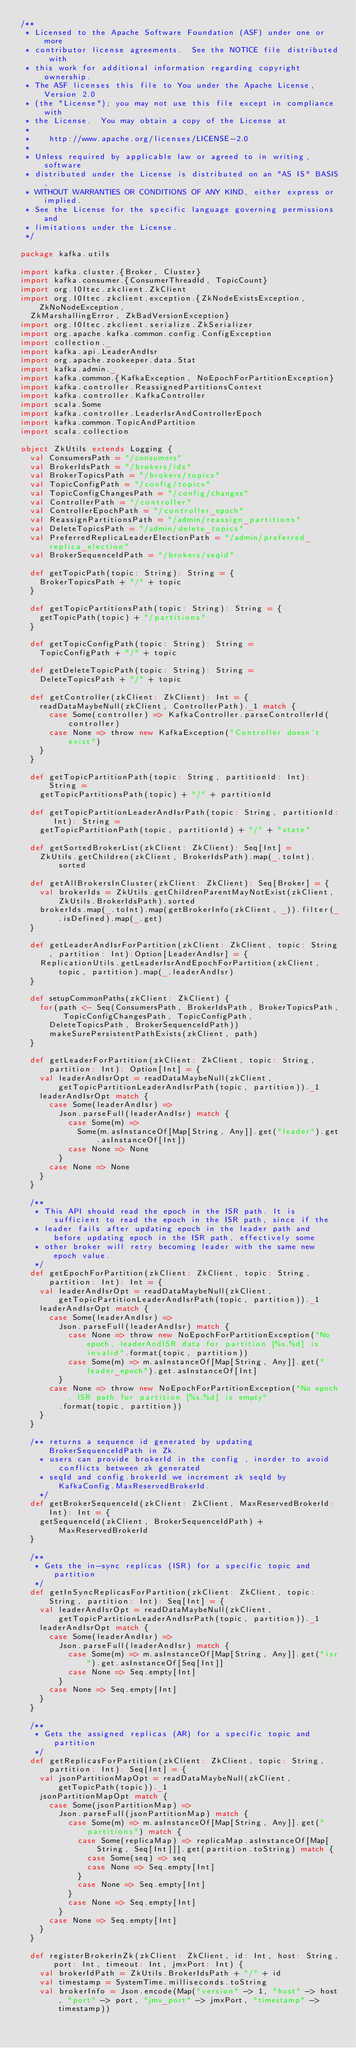Convert code to text. <code><loc_0><loc_0><loc_500><loc_500><_Scala_>/**
 * Licensed to the Apache Software Foundation (ASF) under one or more
 * contributor license agreements.  See the NOTICE file distributed with
 * this work for additional information regarding copyright ownership.
 * The ASF licenses this file to You under the Apache License, Version 2.0
 * (the "License"); you may not use this file except in compliance with
 * the License.  You may obtain a copy of the License at
 *
 *    http://www.apache.org/licenses/LICENSE-2.0
 *
 * Unless required by applicable law or agreed to in writing, software
 * distributed under the License is distributed on an "AS IS" BASIS,
 * WITHOUT WARRANTIES OR CONDITIONS OF ANY KIND, either express or implied.
 * See the License for the specific language governing permissions and
 * limitations under the License.
 */

package kafka.utils

import kafka.cluster.{Broker, Cluster}
import kafka.consumer.{ConsumerThreadId, TopicCount}
import org.I0Itec.zkclient.ZkClient
import org.I0Itec.zkclient.exception.{ZkNodeExistsException, ZkNoNodeException,
  ZkMarshallingError, ZkBadVersionException}
import org.I0Itec.zkclient.serialize.ZkSerializer
import org.apache.kafka.common.config.ConfigException
import collection._
import kafka.api.LeaderAndIsr
import org.apache.zookeeper.data.Stat
import kafka.admin._
import kafka.common.{KafkaException, NoEpochForPartitionException}
import kafka.controller.ReassignedPartitionsContext
import kafka.controller.KafkaController
import scala.Some
import kafka.controller.LeaderIsrAndControllerEpoch
import kafka.common.TopicAndPartition
import scala.collection

object ZkUtils extends Logging {
  val ConsumersPath = "/consumers"
  val BrokerIdsPath = "/brokers/ids"
  val BrokerTopicsPath = "/brokers/topics"
  val TopicConfigPath = "/config/topics"
  val TopicConfigChangesPath = "/config/changes"
  val ControllerPath = "/controller"
  val ControllerEpochPath = "/controller_epoch"
  val ReassignPartitionsPath = "/admin/reassign_partitions"
  val DeleteTopicsPath = "/admin/delete_topics"
  val PreferredReplicaLeaderElectionPath = "/admin/preferred_replica_election"
  val BrokerSequenceIdPath = "/brokers/seqid"

  def getTopicPath(topic: String): String = {
    BrokerTopicsPath + "/" + topic
  }

  def getTopicPartitionsPath(topic: String): String = {
    getTopicPath(topic) + "/partitions"
  }

  def getTopicConfigPath(topic: String): String =
    TopicConfigPath + "/" + topic

  def getDeleteTopicPath(topic: String): String =
    DeleteTopicsPath + "/" + topic

  def getController(zkClient: ZkClient): Int = {
    readDataMaybeNull(zkClient, ControllerPath)._1 match {
      case Some(controller) => KafkaController.parseControllerId(controller)
      case None => throw new KafkaException("Controller doesn't exist")
    }
  }

  def getTopicPartitionPath(topic: String, partitionId: Int): String =
    getTopicPartitionsPath(topic) + "/" + partitionId

  def getTopicPartitionLeaderAndIsrPath(topic: String, partitionId: Int): String =
    getTopicPartitionPath(topic, partitionId) + "/" + "state"

  def getSortedBrokerList(zkClient: ZkClient): Seq[Int] =
    ZkUtils.getChildren(zkClient, BrokerIdsPath).map(_.toInt).sorted

  def getAllBrokersInCluster(zkClient: ZkClient): Seq[Broker] = {
    val brokerIds = ZkUtils.getChildrenParentMayNotExist(zkClient, ZkUtils.BrokerIdsPath).sorted
    brokerIds.map(_.toInt).map(getBrokerInfo(zkClient, _)).filter(_.isDefined).map(_.get)
  }

  def getLeaderAndIsrForPartition(zkClient: ZkClient, topic: String, partition: Int):Option[LeaderAndIsr] = {
    ReplicationUtils.getLeaderIsrAndEpochForPartition(zkClient, topic, partition).map(_.leaderAndIsr)
  }

  def setupCommonPaths(zkClient: ZkClient) {
    for(path <- Seq(ConsumersPath, BrokerIdsPath, BrokerTopicsPath, TopicConfigChangesPath, TopicConfigPath,
      DeleteTopicsPath, BrokerSequenceIdPath))
      makeSurePersistentPathExists(zkClient, path)
  }

  def getLeaderForPartition(zkClient: ZkClient, topic: String, partition: Int): Option[Int] = {
    val leaderAndIsrOpt = readDataMaybeNull(zkClient, getTopicPartitionLeaderAndIsrPath(topic, partition))._1
    leaderAndIsrOpt match {
      case Some(leaderAndIsr) =>
        Json.parseFull(leaderAndIsr) match {
          case Some(m) =>
            Some(m.asInstanceOf[Map[String, Any]].get("leader").get.asInstanceOf[Int])
          case None => None
        }
      case None => None
    }
  }

  /**
   * This API should read the epoch in the ISR path. It is sufficient to read the epoch in the ISR path, since if the
   * leader fails after updating epoch in the leader path and before updating epoch in the ISR path, effectively some
   * other broker will retry becoming leader with the same new epoch value.
   */
  def getEpochForPartition(zkClient: ZkClient, topic: String, partition: Int): Int = {
    val leaderAndIsrOpt = readDataMaybeNull(zkClient, getTopicPartitionLeaderAndIsrPath(topic, partition))._1
    leaderAndIsrOpt match {
      case Some(leaderAndIsr) =>
        Json.parseFull(leaderAndIsr) match {
          case None => throw new NoEpochForPartitionException("No epoch, leaderAndISR data for partition [%s,%d] is invalid".format(topic, partition))
          case Some(m) => m.asInstanceOf[Map[String, Any]].get("leader_epoch").get.asInstanceOf[Int]
        }
      case None => throw new NoEpochForPartitionException("No epoch, ISR path for partition [%s,%d] is empty"
        .format(topic, partition))
    }
  }

  /** returns a sequence id generated by updating BrokerSequenceIdPath in Zk.
    * users can provide brokerId in the config , inorder to avoid conflicts between zk generated
    * seqId and config.brokerId we increment zk seqId by KafkaConfig.MaxReservedBrokerId.
    */
  def getBrokerSequenceId(zkClient: ZkClient, MaxReservedBrokerId: Int): Int = {
    getSequenceId(zkClient, BrokerSequenceIdPath) + MaxReservedBrokerId
  }

  /**
   * Gets the in-sync replicas (ISR) for a specific topic and partition
   */
  def getInSyncReplicasForPartition(zkClient: ZkClient, topic: String, partition: Int): Seq[Int] = {
    val leaderAndIsrOpt = readDataMaybeNull(zkClient, getTopicPartitionLeaderAndIsrPath(topic, partition))._1
    leaderAndIsrOpt match {
      case Some(leaderAndIsr) =>
        Json.parseFull(leaderAndIsr) match {
          case Some(m) => m.asInstanceOf[Map[String, Any]].get("isr").get.asInstanceOf[Seq[Int]]
          case None => Seq.empty[Int]
        }
      case None => Seq.empty[Int]
    }
  }

  /**
   * Gets the assigned replicas (AR) for a specific topic and partition
   */
  def getReplicasForPartition(zkClient: ZkClient, topic: String, partition: Int): Seq[Int] = {
    val jsonPartitionMapOpt = readDataMaybeNull(zkClient, getTopicPath(topic))._1
    jsonPartitionMapOpt match {
      case Some(jsonPartitionMap) =>
        Json.parseFull(jsonPartitionMap) match {
          case Some(m) => m.asInstanceOf[Map[String, Any]].get("partitions") match {
            case Some(replicaMap) => replicaMap.asInstanceOf[Map[String, Seq[Int]]].get(partition.toString) match {
              case Some(seq) => seq
              case None => Seq.empty[Int]
            }
            case None => Seq.empty[Int]
          }
          case None => Seq.empty[Int]
        }
      case None => Seq.empty[Int]
    }
  }

  def registerBrokerInZk(zkClient: ZkClient, id: Int, host: String, port: Int, timeout: Int, jmxPort: Int) {
    val brokerIdPath = ZkUtils.BrokerIdsPath + "/" + id
    val timestamp = SystemTime.milliseconds.toString
    val brokerInfo = Json.encode(Map("version" -> 1, "host" -> host, "port" -> port, "jmx_port" -> jmxPort, "timestamp" -> timestamp))</code> 